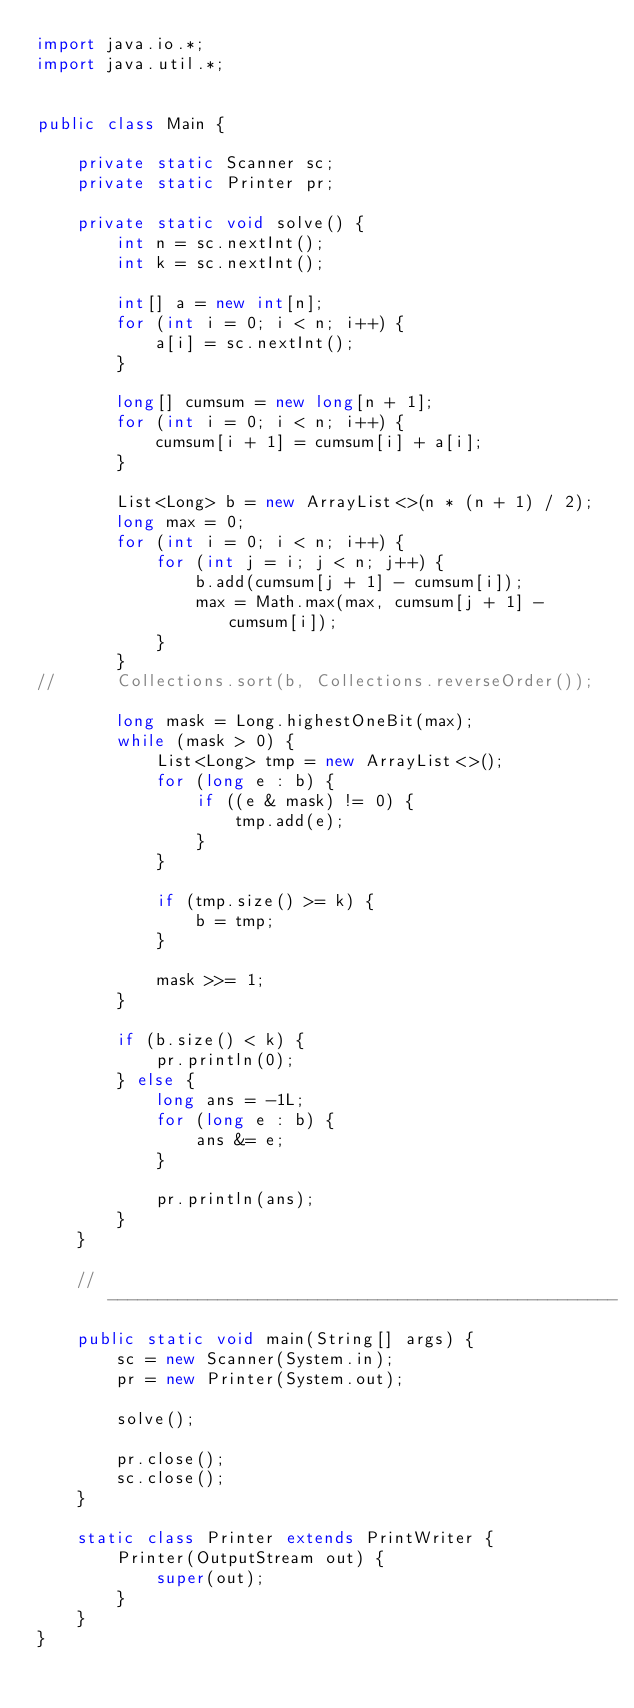<code> <loc_0><loc_0><loc_500><loc_500><_Java_>import java.io.*;
import java.util.*;


public class Main {

	private static Scanner sc;
	private static Printer pr;

	private static void solve() {
		int n = sc.nextInt();
		int k = sc.nextInt();

		int[] a = new int[n];
		for (int i = 0; i < n; i++) {
			a[i] = sc.nextInt();
		}
		
		long[] cumsum = new long[n + 1];
		for (int i = 0; i < n; i++) {
			cumsum[i + 1] = cumsum[i] + a[i];
		}

		List<Long> b = new ArrayList<>(n * (n + 1) / 2);
		long max = 0;
		for (int i = 0; i < n; i++) {
			for (int j = i; j < n; j++) {
				b.add(cumsum[j + 1] - cumsum[i]);
				max = Math.max(max, cumsum[j + 1] - cumsum[i]);
			}
		}
//		Collections.sort(b, Collections.reverseOrder());

		long mask = Long.highestOneBit(max);
		while (mask > 0) {
			List<Long> tmp = new ArrayList<>();
			for (long e : b) {
				if ((e & mask) != 0) {
					tmp.add(e);
				}
			}
			
			if (tmp.size() >= k) {
				b = tmp;
			}
			
			mask >>= 1;
		}
		
		if (b.size() < k) {
			pr.println(0);
		} else {
			long ans = -1L;
			for (long e : b) {
				ans &= e;
			}
			
			pr.println(ans);
		}
	}

	// ---------------------------------------------------
	public static void main(String[] args) {
		sc = new Scanner(System.in);
		pr = new Printer(System.out);
			
		solve();
			
		pr.close();
		sc.close();
	}

	static class Printer extends PrintWriter {
		Printer(OutputStream out) {
			super(out);
		}
	}
}
</code> 